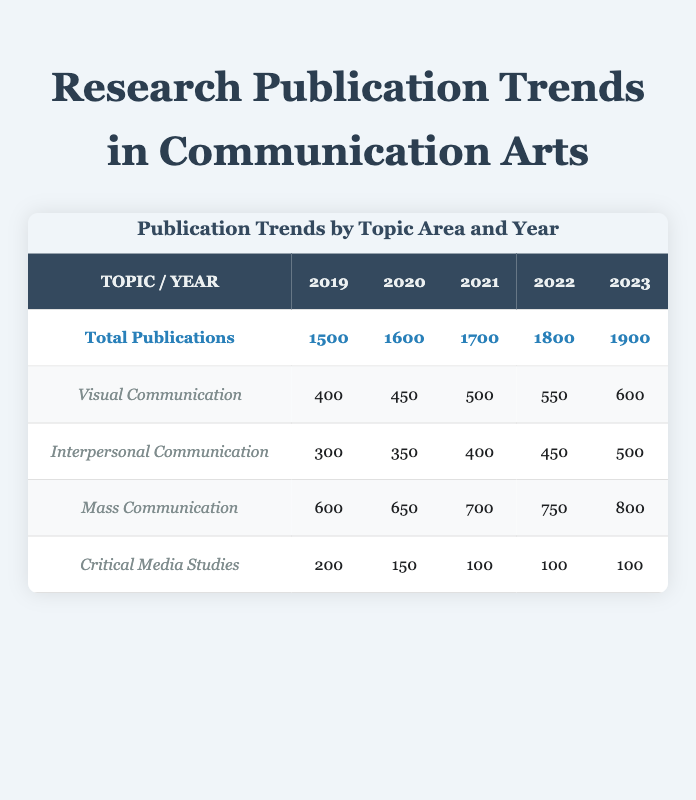What was the total number of publications in 2020? The total number of publications for the year 2020 can be found in the row for Total Publications. It shows the number as 1600.
Answer: 1600 Which subtopic had the highest number of publications in 2021? By comparing the numbers in the subtopic rows for the year 2021, Mass Communication has the highest number of publications with 700.
Answer: Mass Communication What is the percentage increase in total publications from 2019 to 2023? To calculate the percentage increase, take the total for 2023 (1900), subtract the total for 2019 (1500) to get an increase of 400. Then divide the increase (400) by the original number (1500) and multiply by 100, which results in approximately 26.67%.
Answer: 26.67% Did the number of publications for Critical Media Studies ever exceed 200 in 2020? Looking at the row for Critical Media Studies in 2020, the number of publications is 150, which is less than 200. Therefore, the answer is no.
Answer: No What is the average number of publications for Visual Communication over the years? The total for Visual Communication over the years is 400 (2019) + 450 (2020) + 500 (2021) + 550 (2022) + 600 (2023) = 2500. Divide this by 5 (the number of years) to get an average of 500.
Answer: 500 What was the trend in Interpersonal Communication publications from 2019 to 2023? By analyzing the data, publications increased from 300 in 2019 to 500 in 2023, indicating a consistent upward trend over the years.
Answer: Upward trend How many more publications were there in Mass Communication compared to Visual Communication in 2022? For 2022, Mass Communication has 750 publications and Visual Communication has 550. The difference is 750 - 550 = 200.
Answer: 200 Was there a decrease in publications for Critical Media Studies in any year compared to the previous year? Yes, there was a decrease in publications for Critical Media Studies from 2019 (200) to 2020 (150) and from 2020 to 2021 (100). Thus, it did decrease in those years.
Answer: Yes What is the total number of publications across all subtopics in 2023? In 2023, the total publications across subtopics are 600 (Visual) + 500 (Interpersonal) + 800 (Mass) + 100 (Critical) = 2000. Thus, the total is 1900 as reported in the Total Publications row.
Answer: 2000 